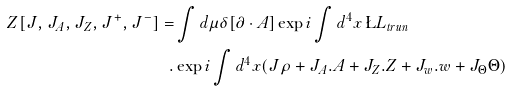Convert formula to latex. <formula><loc_0><loc_0><loc_500><loc_500>Z [ J , { J } _ { A } , { J } _ { Z } , { J } ^ { + } , { J } ^ { - } ] = & \int d \mu \delta [ \partial \cdot { A } ] \exp { i \int d ^ { 4 } x \, \L L _ { t r u n } } \\ . & \exp { i \int d ^ { 4 } x ( J \rho + { J } _ { A } . { A } + { J } _ { Z } . Z + { J } _ { w } . w + J _ { \Theta } \Theta ) }</formula> 